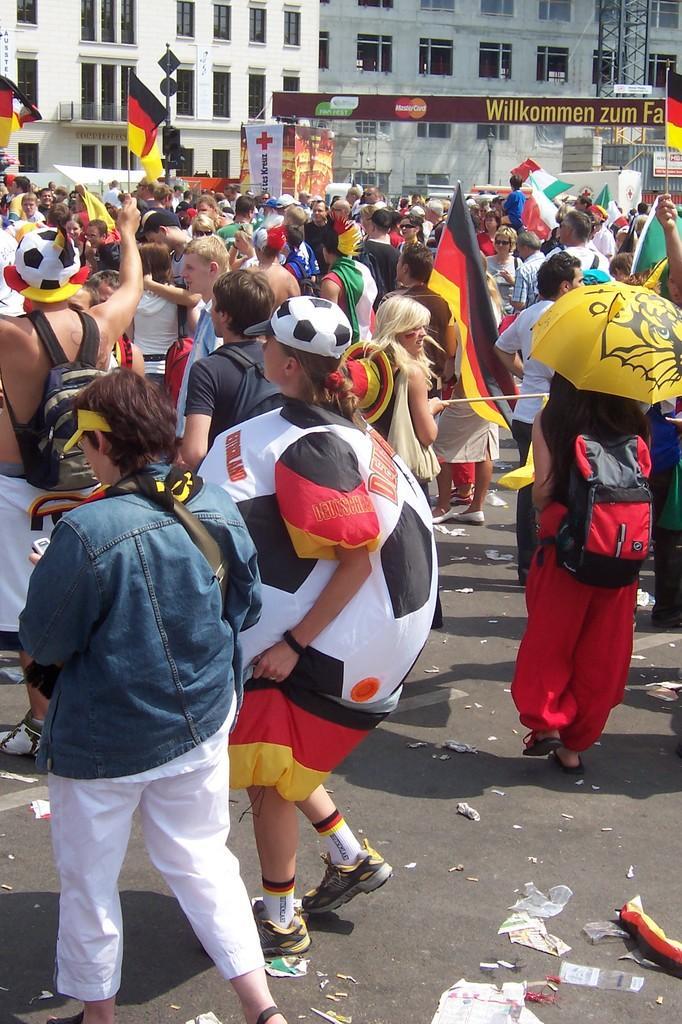How would you summarize this image in a sentence or two? In this image we can see people, flags, hoardings and buildings. Few people are holding flags and umbrella. Far there is a light pole and sign boards. 